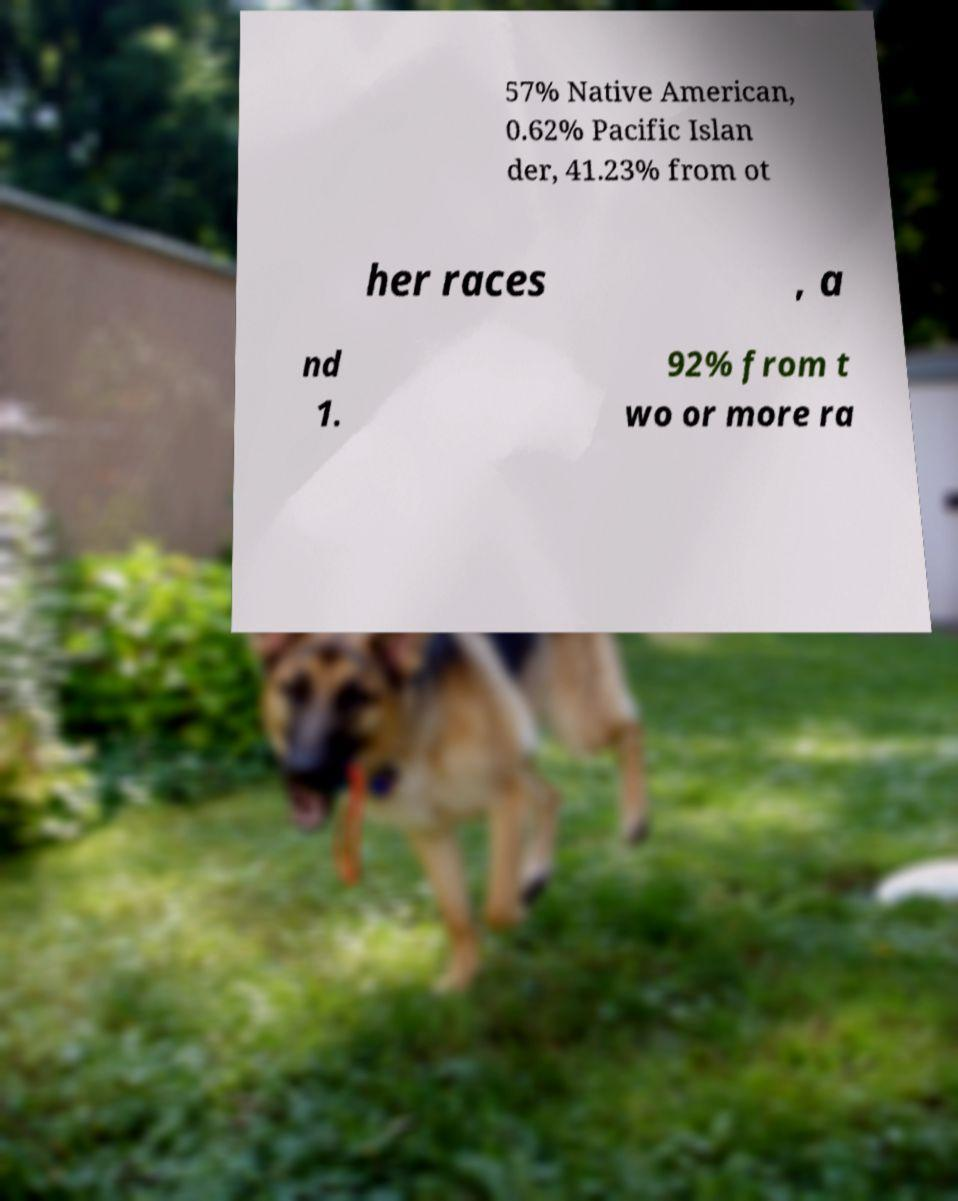Please identify and transcribe the text found in this image. 57% Native American, 0.62% Pacific Islan der, 41.23% from ot her races , a nd 1. 92% from t wo or more ra 